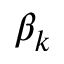Convert formula to latex. <formula><loc_0><loc_0><loc_500><loc_500>\beta _ { k }</formula> 